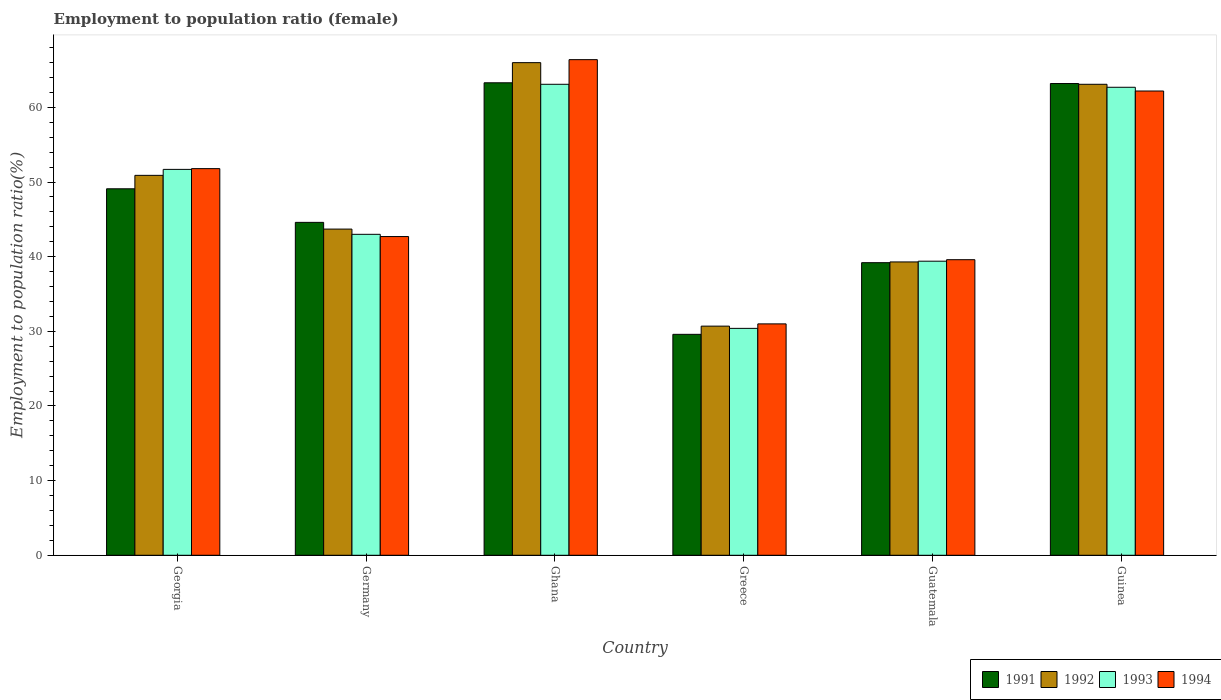Are the number of bars per tick equal to the number of legend labels?
Make the answer very short. Yes. How many bars are there on the 2nd tick from the left?
Make the answer very short. 4. What is the label of the 6th group of bars from the left?
Your answer should be very brief. Guinea. What is the employment to population ratio in 1994 in Germany?
Offer a very short reply. 42.7. Across all countries, what is the maximum employment to population ratio in 1993?
Your response must be concise. 63.1. Across all countries, what is the minimum employment to population ratio in 1992?
Offer a very short reply. 30.7. In which country was the employment to population ratio in 1993 maximum?
Make the answer very short. Ghana. What is the total employment to population ratio in 1993 in the graph?
Ensure brevity in your answer.  290.3. What is the difference between the employment to population ratio in 1994 in Ghana and that in Guatemala?
Offer a terse response. 26.8. What is the difference between the employment to population ratio in 1993 in Guinea and the employment to population ratio in 1994 in Germany?
Provide a short and direct response. 20. What is the average employment to population ratio in 1993 per country?
Your answer should be compact. 48.38. What is the difference between the employment to population ratio of/in 1991 and employment to population ratio of/in 1994 in Guinea?
Your response must be concise. 1. In how many countries, is the employment to population ratio in 1994 greater than 34 %?
Provide a short and direct response. 5. What is the ratio of the employment to population ratio in 1992 in Georgia to that in Germany?
Your answer should be very brief. 1.16. Is the difference between the employment to population ratio in 1991 in Ghana and Guinea greater than the difference between the employment to population ratio in 1994 in Ghana and Guinea?
Keep it short and to the point. No. What is the difference between the highest and the second highest employment to population ratio in 1991?
Offer a very short reply. -14.1. What is the difference between the highest and the lowest employment to population ratio in 1991?
Provide a succinct answer. 33.7. In how many countries, is the employment to population ratio in 1993 greater than the average employment to population ratio in 1993 taken over all countries?
Offer a very short reply. 3. Is it the case that in every country, the sum of the employment to population ratio in 1991 and employment to population ratio in 1993 is greater than the sum of employment to population ratio in 1994 and employment to population ratio in 1992?
Your answer should be very brief. No. What does the 3rd bar from the right in Ghana represents?
Your answer should be compact. 1992. How many bars are there?
Your answer should be compact. 24. Are all the bars in the graph horizontal?
Your response must be concise. No. How many countries are there in the graph?
Your answer should be compact. 6. What is the difference between two consecutive major ticks on the Y-axis?
Make the answer very short. 10. Does the graph contain grids?
Your response must be concise. No. How many legend labels are there?
Make the answer very short. 4. What is the title of the graph?
Your answer should be very brief. Employment to population ratio (female). What is the Employment to population ratio(%) of 1991 in Georgia?
Provide a short and direct response. 49.1. What is the Employment to population ratio(%) of 1992 in Georgia?
Make the answer very short. 50.9. What is the Employment to population ratio(%) in 1993 in Georgia?
Your response must be concise. 51.7. What is the Employment to population ratio(%) in 1994 in Georgia?
Ensure brevity in your answer.  51.8. What is the Employment to population ratio(%) in 1991 in Germany?
Provide a short and direct response. 44.6. What is the Employment to population ratio(%) of 1992 in Germany?
Provide a short and direct response. 43.7. What is the Employment to population ratio(%) in 1994 in Germany?
Give a very brief answer. 42.7. What is the Employment to population ratio(%) in 1991 in Ghana?
Provide a short and direct response. 63.3. What is the Employment to population ratio(%) of 1993 in Ghana?
Your answer should be very brief. 63.1. What is the Employment to population ratio(%) of 1994 in Ghana?
Give a very brief answer. 66.4. What is the Employment to population ratio(%) in 1991 in Greece?
Provide a short and direct response. 29.6. What is the Employment to population ratio(%) of 1992 in Greece?
Make the answer very short. 30.7. What is the Employment to population ratio(%) of 1993 in Greece?
Your response must be concise. 30.4. What is the Employment to population ratio(%) of 1994 in Greece?
Offer a very short reply. 31. What is the Employment to population ratio(%) in 1991 in Guatemala?
Make the answer very short. 39.2. What is the Employment to population ratio(%) in 1992 in Guatemala?
Your answer should be compact. 39.3. What is the Employment to population ratio(%) in 1993 in Guatemala?
Ensure brevity in your answer.  39.4. What is the Employment to population ratio(%) in 1994 in Guatemala?
Offer a very short reply. 39.6. What is the Employment to population ratio(%) in 1991 in Guinea?
Ensure brevity in your answer.  63.2. What is the Employment to population ratio(%) in 1992 in Guinea?
Give a very brief answer. 63.1. What is the Employment to population ratio(%) in 1993 in Guinea?
Your answer should be compact. 62.7. What is the Employment to population ratio(%) of 1994 in Guinea?
Offer a very short reply. 62.2. Across all countries, what is the maximum Employment to population ratio(%) in 1991?
Your answer should be very brief. 63.3. Across all countries, what is the maximum Employment to population ratio(%) in 1992?
Give a very brief answer. 66. Across all countries, what is the maximum Employment to population ratio(%) of 1993?
Make the answer very short. 63.1. Across all countries, what is the maximum Employment to population ratio(%) of 1994?
Ensure brevity in your answer.  66.4. Across all countries, what is the minimum Employment to population ratio(%) in 1991?
Give a very brief answer. 29.6. Across all countries, what is the minimum Employment to population ratio(%) of 1992?
Give a very brief answer. 30.7. Across all countries, what is the minimum Employment to population ratio(%) in 1993?
Provide a succinct answer. 30.4. What is the total Employment to population ratio(%) in 1991 in the graph?
Provide a succinct answer. 289. What is the total Employment to population ratio(%) in 1992 in the graph?
Make the answer very short. 293.7. What is the total Employment to population ratio(%) in 1993 in the graph?
Offer a very short reply. 290.3. What is the total Employment to population ratio(%) in 1994 in the graph?
Your answer should be very brief. 293.7. What is the difference between the Employment to population ratio(%) of 1993 in Georgia and that in Germany?
Offer a very short reply. 8.7. What is the difference between the Employment to population ratio(%) in 1992 in Georgia and that in Ghana?
Offer a very short reply. -15.1. What is the difference between the Employment to population ratio(%) in 1993 in Georgia and that in Ghana?
Provide a succinct answer. -11.4. What is the difference between the Employment to population ratio(%) of 1994 in Georgia and that in Ghana?
Offer a very short reply. -14.6. What is the difference between the Employment to population ratio(%) in 1991 in Georgia and that in Greece?
Give a very brief answer. 19.5. What is the difference between the Employment to population ratio(%) of 1992 in Georgia and that in Greece?
Offer a very short reply. 20.2. What is the difference between the Employment to population ratio(%) of 1993 in Georgia and that in Greece?
Keep it short and to the point. 21.3. What is the difference between the Employment to population ratio(%) in 1994 in Georgia and that in Greece?
Offer a terse response. 20.8. What is the difference between the Employment to population ratio(%) in 1991 in Georgia and that in Guatemala?
Keep it short and to the point. 9.9. What is the difference between the Employment to population ratio(%) of 1992 in Georgia and that in Guatemala?
Provide a short and direct response. 11.6. What is the difference between the Employment to population ratio(%) in 1994 in Georgia and that in Guatemala?
Keep it short and to the point. 12.2. What is the difference between the Employment to population ratio(%) in 1991 in Georgia and that in Guinea?
Give a very brief answer. -14.1. What is the difference between the Employment to population ratio(%) in 1993 in Georgia and that in Guinea?
Offer a terse response. -11. What is the difference between the Employment to population ratio(%) of 1991 in Germany and that in Ghana?
Your answer should be compact. -18.7. What is the difference between the Employment to population ratio(%) of 1992 in Germany and that in Ghana?
Your response must be concise. -22.3. What is the difference between the Employment to population ratio(%) of 1993 in Germany and that in Ghana?
Ensure brevity in your answer.  -20.1. What is the difference between the Employment to population ratio(%) of 1994 in Germany and that in Ghana?
Your answer should be very brief. -23.7. What is the difference between the Employment to population ratio(%) in 1991 in Germany and that in Greece?
Ensure brevity in your answer.  15. What is the difference between the Employment to population ratio(%) of 1994 in Germany and that in Greece?
Provide a succinct answer. 11.7. What is the difference between the Employment to population ratio(%) of 1994 in Germany and that in Guatemala?
Make the answer very short. 3.1. What is the difference between the Employment to population ratio(%) of 1991 in Germany and that in Guinea?
Offer a terse response. -18.6. What is the difference between the Employment to population ratio(%) in 1992 in Germany and that in Guinea?
Keep it short and to the point. -19.4. What is the difference between the Employment to population ratio(%) in 1993 in Germany and that in Guinea?
Your answer should be compact. -19.7. What is the difference between the Employment to population ratio(%) of 1994 in Germany and that in Guinea?
Your answer should be very brief. -19.5. What is the difference between the Employment to population ratio(%) of 1991 in Ghana and that in Greece?
Keep it short and to the point. 33.7. What is the difference between the Employment to population ratio(%) in 1992 in Ghana and that in Greece?
Your response must be concise. 35.3. What is the difference between the Employment to population ratio(%) in 1993 in Ghana and that in Greece?
Provide a short and direct response. 32.7. What is the difference between the Employment to population ratio(%) of 1994 in Ghana and that in Greece?
Ensure brevity in your answer.  35.4. What is the difference between the Employment to population ratio(%) of 1991 in Ghana and that in Guatemala?
Your answer should be very brief. 24.1. What is the difference between the Employment to population ratio(%) of 1992 in Ghana and that in Guatemala?
Offer a terse response. 26.7. What is the difference between the Employment to population ratio(%) of 1993 in Ghana and that in Guatemala?
Make the answer very short. 23.7. What is the difference between the Employment to population ratio(%) of 1994 in Ghana and that in Guatemala?
Ensure brevity in your answer.  26.8. What is the difference between the Employment to population ratio(%) of 1991 in Ghana and that in Guinea?
Your answer should be very brief. 0.1. What is the difference between the Employment to population ratio(%) in 1994 in Ghana and that in Guinea?
Offer a terse response. 4.2. What is the difference between the Employment to population ratio(%) in 1992 in Greece and that in Guatemala?
Your answer should be very brief. -8.6. What is the difference between the Employment to population ratio(%) in 1993 in Greece and that in Guatemala?
Offer a terse response. -9. What is the difference between the Employment to population ratio(%) of 1991 in Greece and that in Guinea?
Make the answer very short. -33.6. What is the difference between the Employment to population ratio(%) in 1992 in Greece and that in Guinea?
Your answer should be very brief. -32.4. What is the difference between the Employment to population ratio(%) of 1993 in Greece and that in Guinea?
Give a very brief answer. -32.3. What is the difference between the Employment to population ratio(%) in 1994 in Greece and that in Guinea?
Your response must be concise. -31.2. What is the difference between the Employment to population ratio(%) of 1991 in Guatemala and that in Guinea?
Your answer should be very brief. -24. What is the difference between the Employment to population ratio(%) of 1992 in Guatemala and that in Guinea?
Provide a succinct answer. -23.8. What is the difference between the Employment to population ratio(%) in 1993 in Guatemala and that in Guinea?
Ensure brevity in your answer.  -23.3. What is the difference between the Employment to population ratio(%) in 1994 in Guatemala and that in Guinea?
Offer a very short reply. -22.6. What is the difference between the Employment to population ratio(%) of 1991 in Georgia and the Employment to population ratio(%) of 1992 in Germany?
Make the answer very short. 5.4. What is the difference between the Employment to population ratio(%) in 1991 in Georgia and the Employment to population ratio(%) in 1993 in Germany?
Offer a very short reply. 6.1. What is the difference between the Employment to population ratio(%) in 1992 in Georgia and the Employment to population ratio(%) in 1994 in Germany?
Provide a short and direct response. 8.2. What is the difference between the Employment to population ratio(%) in 1991 in Georgia and the Employment to population ratio(%) in 1992 in Ghana?
Your response must be concise. -16.9. What is the difference between the Employment to population ratio(%) of 1991 in Georgia and the Employment to population ratio(%) of 1994 in Ghana?
Offer a very short reply. -17.3. What is the difference between the Employment to population ratio(%) of 1992 in Georgia and the Employment to population ratio(%) of 1994 in Ghana?
Offer a terse response. -15.5. What is the difference between the Employment to population ratio(%) in 1993 in Georgia and the Employment to population ratio(%) in 1994 in Ghana?
Give a very brief answer. -14.7. What is the difference between the Employment to population ratio(%) of 1993 in Georgia and the Employment to population ratio(%) of 1994 in Greece?
Give a very brief answer. 20.7. What is the difference between the Employment to population ratio(%) in 1991 in Georgia and the Employment to population ratio(%) in 1992 in Guatemala?
Your answer should be very brief. 9.8. What is the difference between the Employment to population ratio(%) of 1991 in Georgia and the Employment to population ratio(%) of 1993 in Guatemala?
Your answer should be very brief. 9.7. What is the difference between the Employment to population ratio(%) of 1991 in Georgia and the Employment to population ratio(%) of 1994 in Guatemala?
Provide a succinct answer. 9.5. What is the difference between the Employment to population ratio(%) in 1992 in Georgia and the Employment to population ratio(%) in 1993 in Guatemala?
Your answer should be compact. 11.5. What is the difference between the Employment to population ratio(%) of 1991 in Georgia and the Employment to population ratio(%) of 1993 in Guinea?
Provide a succinct answer. -13.6. What is the difference between the Employment to population ratio(%) in 1993 in Georgia and the Employment to population ratio(%) in 1994 in Guinea?
Give a very brief answer. -10.5. What is the difference between the Employment to population ratio(%) of 1991 in Germany and the Employment to population ratio(%) of 1992 in Ghana?
Ensure brevity in your answer.  -21.4. What is the difference between the Employment to population ratio(%) of 1991 in Germany and the Employment to population ratio(%) of 1993 in Ghana?
Your response must be concise. -18.5. What is the difference between the Employment to population ratio(%) in 1991 in Germany and the Employment to population ratio(%) in 1994 in Ghana?
Make the answer very short. -21.8. What is the difference between the Employment to population ratio(%) in 1992 in Germany and the Employment to population ratio(%) in 1993 in Ghana?
Keep it short and to the point. -19.4. What is the difference between the Employment to population ratio(%) in 1992 in Germany and the Employment to population ratio(%) in 1994 in Ghana?
Ensure brevity in your answer.  -22.7. What is the difference between the Employment to population ratio(%) in 1993 in Germany and the Employment to population ratio(%) in 1994 in Ghana?
Keep it short and to the point. -23.4. What is the difference between the Employment to population ratio(%) of 1991 in Germany and the Employment to population ratio(%) of 1992 in Greece?
Your response must be concise. 13.9. What is the difference between the Employment to population ratio(%) of 1992 in Germany and the Employment to population ratio(%) of 1994 in Greece?
Your answer should be compact. 12.7. What is the difference between the Employment to population ratio(%) of 1993 in Germany and the Employment to population ratio(%) of 1994 in Greece?
Ensure brevity in your answer.  12. What is the difference between the Employment to population ratio(%) of 1992 in Germany and the Employment to population ratio(%) of 1994 in Guatemala?
Ensure brevity in your answer.  4.1. What is the difference between the Employment to population ratio(%) in 1993 in Germany and the Employment to population ratio(%) in 1994 in Guatemala?
Keep it short and to the point. 3.4. What is the difference between the Employment to population ratio(%) of 1991 in Germany and the Employment to population ratio(%) of 1992 in Guinea?
Provide a short and direct response. -18.5. What is the difference between the Employment to population ratio(%) in 1991 in Germany and the Employment to population ratio(%) in 1993 in Guinea?
Ensure brevity in your answer.  -18.1. What is the difference between the Employment to population ratio(%) of 1991 in Germany and the Employment to population ratio(%) of 1994 in Guinea?
Keep it short and to the point. -17.6. What is the difference between the Employment to population ratio(%) in 1992 in Germany and the Employment to population ratio(%) in 1994 in Guinea?
Provide a short and direct response. -18.5. What is the difference between the Employment to population ratio(%) in 1993 in Germany and the Employment to population ratio(%) in 1994 in Guinea?
Provide a succinct answer. -19.2. What is the difference between the Employment to population ratio(%) of 1991 in Ghana and the Employment to population ratio(%) of 1992 in Greece?
Your response must be concise. 32.6. What is the difference between the Employment to population ratio(%) in 1991 in Ghana and the Employment to population ratio(%) in 1993 in Greece?
Give a very brief answer. 32.9. What is the difference between the Employment to population ratio(%) in 1991 in Ghana and the Employment to population ratio(%) in 1994 in Greece?
Give a very brief answer. 32.3. What is the difference between the Employment to population ratio(%) of 1992 in Ghana and the Employment to population ratio(%) of 1993 in Greece?
Keep it short and to the point. 35.6. What is the difference between the Employment to population ratio(%) in 1992 in Ghana and the Employment to population ratio(%) in 1994 in Greece?
Your answer should be very brief. 35. What is the difference between the Employment to population ratio(%) in 1993 in Ghana and the Employment to population ratio(%) in 1994 in Greece?
Offer a terse response. 32.1. What is the difference between the Employment to population ratio(%) in 1991 in Ghana and the Employment to population ratio(%) in 1992 in Guatemala?
Your answer should be very brief. 24. What is the difference between the Employment to population ratio(%) in 1991 in Ghana and the Employment to population ratio(%) in 1993 in Guatemala?
Offer a very short reply. 23.9. What is the difference between the Employment to population ratio(%) of 1991 in Ghana and the Employment to population ratio(%) of 1994 in Guatemala?
Ensure brevity in your answer.  23.7. What is the difference between the Employment to population ratio(%) in 1992 in Ghana and the Employment to population ratio(%) in 1993 in Guatemala?
Your response must be concise. 26.6. What is the difference between the Employment to population ratio(%) in 1992 in Ghana and the Employment to population ratio(%) in 1994 in Guatemala?
Ensure brevity in your answer.  26.4. What is the difference between the Employment to population ratio(%) in 1991 in Greece and the Employment to population ratio(%) in 1993 in Guatemala?
Ensure brevity in your answer.  -9.8. What is the difference between the Employment to population ratio(%) in 1991 in Greece and the Employment to population ratio(%) in 1994 in Guatemala?
Make the answer very short. -10. What is the difference between the Employment to population ratio(%) of 1992 in Greece and the Employment to population ratio(%) of 1994 in Guatemala?
Your answer should be compact. -8.9. What is the difference between the Employment to population ratio(%) of 1993 in Greece and the Employment to population ratio(%) of 1994 in Guatemala?
Provide a succinct answer. -9.2. What is the difference between the Employment to population ratio(%) in 1991 in Greece and the Employment to population ratio(%) in 1992 in Guinea?
Ensure brevity in your answer.  -33.5. What is the difference between the Employment to population ratio(%) of 1991 in Greece and the Employment to population ratio(%) of 1993 in Guinea?
Your response must be concise. -33.1. What is the difference between the Employment to population ratio(%) in 1991 in Greece and the Employment to population ratio(%) in 1994 in Guinea?
Your response must be concise. -32.6. What is the difference between the Employment to population ratio(%) in 1992 in Greece and the Employment to population ratio(%) in 1993 in Guinea?
Keep it short and to the point. -32. What is the difference between the Employment to population ratio(%) of 1992 in Greece and the Employment to population ratio(%) of 1994 in Guinea?
Offer a terse response. -31.5. What is the difference between the Employment to population ratio(%) in 1993 in Greece and the Employment to population ratio(%) in 1994 in Guinea?
Provide a succinct answer. -31.8. What is the difference between the Employment to population ratio(%) of 1991 in Guatemala and the Employment to population ratio(%) of 1992 in Guinea?
Provide a succinct answer. -23.9. What is the difference between the Employment to population ratio(%) of 1991 in Guatemala and the Employment to population ratio(%) of 1993 in Guinea?
Provide a short and direct response. -23.5. What is the difference between the Employment to population ratio(%) of 1991 in Guatemala and the Employment to population ratio(%) of 1994 in Guinea?
Make the answer very short. -23. What is the difference between the Employment to population ratio(%) of 1992 in Guatemala and the Employment to population ratio(%) of 1993 in Guinea?
Make the answer very short. -23.4. What is the difference between the Employment to population ratio(%) of 1992 in Guatemala and the Employment to population ratio(%) of 1994 in Guinea?
Ensure brevity in your answer.  -22.9. What is the difference between the Employment to population ratio(%) of 1993 in Guatemala and the Employment to population ratio(%) of 1994 in Guinea?
Keep it short and to the point. -22.8. What is the average Employment to population ratio(%) of 1991 per country?
Give a very brief answer. 48.17. What is the average Employment to population ratio(%) of 1992 per country?
Give a very brief answer. 48.95. What is the average Employment to population ratio(%) in 1993 per country?
Provide a succinct answer. 48.38. What is the average Employment to population ratio(%) of 1994 per country?
Provide a short and direct response. 48.95. What is the difference between the Employment to population ratio(%) in 1991 and Employment to population ratio(%) in 1992 in Georgia?
Ensure brevity in your answer.  -1.8. What is the difference between the Employment to population ratio(%) in 1991 and Employment to population ratio(%) in 1993 in Georgia?
Your answer should be compact. -2.6. What is the difference between the Employment to population ratio(%) in 1992 and Employment to population ratio(%) in 1993 in Georgia?
Give a very brief answer. -0.8. What is the difference between the Employment to population ratio(%) in 1993 and Employment to population ratio(%) in 1994 in Georgia?
Provide a succinct answer. -0.1. What is the difference between the Employment to population ratio(%) in 1991 and Employment to population ratio(%) in 1993 in Germany?
Your answer should be compact. 1.6. What is the difference between the Employment to population ratio(%) of 1991 and Employment to population ratio(%) of 1994 in Germany?
Your answer should be very brief. 1.9. What is the difference between the Employment to population ratio(%) of 1992 and Employment to population ratio(%) of 1994 in Germany?
Your answer should be compact. 1. What is the difference between the Employment to population ratio(%) in 1991 and Employment to population ratio(%) in 1994 in Ghana?
Offer a terse response. -3.1. What is the difference between the Employment to population ratio(%) of 1992 and Employment to population ratio(%) of 1993 in Ghana?
Provide a short and direct response. 2.9. What is the difference between the Employment to population ratio(%) in 1992 and Employment to population ratio(%) in 1994 in Ghana?
Your answer should be very brief. -0.4. What is the difference between the Employment to population ratio(%) of 1993 and Employment to population ratio(%) of 1994 in Ghana?
Your response must be concise. -3.3. What is the difference between the Employment to population ratio(%) of 1991 and Employment to population ratio(%) of 1993 in Greece?
Your response must be concise. -0.8. What is the difference between the Employment to population ratio(%) in 1991 and Employment to population ratio(%) in 1992 in Guatemala?
Provide a short and direct response. -0.1. What is the difference between the Employment to population ratio(%) in 1991 and Employment to population ratio(%) in 1994 in Guatemala?
Keep it short and to the point. -0.4. What is the difference between the Employment to population ratio(%) of 1992 and Employment to population ratio(%) of 1994 in Guatemala?
Your answer should be compact. -0.3. What is the difference between the Employment to population ratio(%) of 1991 and Employment to population ratio(%) of 1992 in Guinea?
Keep it short and to the point. 0.1. What is the difference between the Employment to population ratio(%) of 1991 and Employment to population ratio(%) of 1993 in Guinea?
Make the answer very short. 0.5. What is the difference between the Employment to population ratio(%) in 1992 and Employment to population ratio(%) in 1993 in Guinea?
Give a very brief answer. 0.4. What is the difference between the Employment to population ratio(%) of 1993 and Employment to population ratio(%) of 1994 in Guinea?
Keep it short and to the point. 0.5. What is the ratio of the Employment to population ratio(%) in 1991 in Georgia to that in Germany?
Keep it short and to the point. 1.1. What is the ratio of the Employment to population ratio(%) of 1992 in Georgia to that in Germany?
Give a very brief answer. 1.16. What is the ratio of the Employment to population ratio(%) of 1993 in Georgia to that in Germany?
Offer a very short reply. 1.2. What is the ratio of the Employment to population ratio(%) in 1994 in Georgia to that in Germany?
Make the answer very short. 1.21. What is the ratio of the Employment to population ratio(%) in 1991 in Georgia to that in Ghana?
Provide a succinct answer. 0.78. What is the ratio of the Employment to population ratio(%) of 1992 in Georgia to that in Ghana?
Your response must be concise. 0.77. What is the ratio of the Employment to population ratio(%) in 1993 in Georgia to that in Ghana?
Offer a terse response. 0.82. What is the ratio of the Employment to population ratio(%) in 1994 in Georgia to that in Ghana?
Offer a terse response. 0.78. What is the ratio of the Employment to population ratio(%) of 1991 in Georgia to that in Greece?
Your response must be concise. 1.66. What is the ratio of the Employment to population ratio(%) of 1992 in Georgia to that in Greece?
Make the answer very short. 1.66. What is the ratio of the Employment to population ratio(%) of 1993 in Georgia to that in Greece?
Keep it short and to the point. 1.7. What is the ratio of the Employment to population ratio(%) of 1994 in Georgia to that in Greece?
Make the answer very short. 1.67. What is the ratio of the Employment to population ratio(%) in 1991 in Georgia to that in Guatemala?
Your answer should be compact. 1.25. What is the ratio of the Employment to population ratio(%) of 1992 in Georgia to that in Guatemala?
Offer a very short reply. 1.3. What is the ratio of the Employment to population ratio(%) of 1993 in Georgia to that in Guatemala?
Offer a very short reply. 1.31. What is the ratio of the Employment to population ratio(%) in 1994 in Georgia to that in Guatemala?
Your answer should be very brief. 1.31. What is the ratio of the Employment to population ratio(%) in 1991 in Georgia to that in Guinea?
Make the answer very short. 0.78. What is the ratio of the Employment to population ratio(%) in 1992 in Georgia to that in Guinea?
Ensure brevity in your answer.  0.81. What is the ratio of the Employment to population ratio(%) of 1993 in Georgia to that in Guinea?
Ensure brevity in your answer.  0.82. What is the ratio of the Employment to population ratio(%) in 1994 in Georgia to that in Guinea?
Keep it short and to the point. 0.83. What is the ratio of the Employment to population ratio(%) of 1991 in Germany to that in Ghana?
Your answer should be very brief. 0.7. What is the ratio of the Employment to population ratio(%) in 1992 in Germany to that in Ghana?
Offer a very short reply. 0.66. What is the ratio of the Employment to population ratio(%) of 1993 in Germany to that in Ghana?
Keep it short and to the point. 0.68. What is the ratio of the Employment to population ratio(%) of 1994 in Germany to that in Ghana?
Your answer should be very brief. 0.64. What is the ratio of the Employment to population ratio(%) of 1991 in Germany to that in Greece?
Give a very brief answer. 1.51. What is the ratio of the Employment to population ratio(%) in 1992 in Germany to that in Greece?
Make the answer very short. 1.42. What is the ratio of the Employment to population ratio(%) in 1993 in Germany to that in Greece?
Ensure brevity in your answer.  1.41. What is the ratio of the Employment to population ratio(%) in 1994 in Germany to that in Greece?
Offer a terse response. 1.38. What is the ratio of the Employment to population ratio(%) in 1991 in Germany to that in Guatemala?
Provide a succinct answer. 1.14. What is the ratio of the Employment to population ratio(%) of 1992 in Germany to that in Guatemala?
Provide a succinct answer. 1.11. What is the ratio of the Employment to population ratio(%) in 1993 in Germany to that in Guatemala?
Your response must be concise. 1.09. What is the ratio of the Employment to population ratio(%) in 1994 in Germany to that in Guatemala?
Offer a very short reply. 1.08. What is the ratio of the Employment to population ratio(%) in 1991 in Germany to that in Guinea?
Provide a short and direct response. 0.71. What is the ratio of the Employment to population ratio(%) of 1992 in Germany to that in Guinea?
Offer a very short reply. 0.69. What is the ratio of the Employment to population ratio(%) in 1993 in Germany to that in Guinea?
Make the answer very short. 0.69. What is the ratio of the Employment to population ratio(%) in 1994 in Germany to that in Guinea?
Offer a terse response. 0.69. What is the ratio of the Employment to population ratio(%) in 1991 in Ghana to that in Greece?
Provide a succinct answer. 2.14. What is the ratio of the Employment to population ratio(%) of 1992 in Ghana to that in Greece?
Provide a short and direct response. 2.15. What is the ratio of the Employment to population ratio(%) of 1993 in Ghana to that in Greece?
Offer a terse response. 2.08. What is the ratio of the Employment to population ratio(%) in 1994 in Ghana to that in Greece?
Ensure brevity in your answer.  2.14. What is the ratio of the Employment to population ratio(%) of 1991 in Ghana to that in Guatemala?
Offer a terse response. 1.61. What is the ratio of the Employment to population ratio(%) of 1992 in Ghana to that in Guatemala?
Ensure brevity in your answer.  1.68. What is the ratio of the Employment to population ratio(%) of 1993 in Ghana to that in Guatemala?
Offer a very short reply. 1.6. What is the ratio of the Employment to population ratio(%) of 1994 in Ghana to that in Guatemala?
Ensure brevity in your answer.  1.68. What is the ratio of the Employment to population ratio(%) in 1991 in Ghana to that in Guinea?
Your response must be concise. 1. What is the ratio of the Employment to population ratio(%) in 1992 in Ghana to that in Guinea?
Ensure brevity in your answer.  1.05. What is the ratio of the Employment to population ratio(%) of 1993 in Ghana to that in Guinea?
Provide a short and direct response. 1.01. What is the ratio of the Employment to population ratio(%) of 1994 in Ghana to that in Guinea?
Offer a terse response. 1.07. What is the ratio of the Employment to population ratio(%) in 1991 in Greece to that in Guatemala?
Make the answer very short. 0.76. What is the ratio of the Employment to population ratio(%) of 1992 in Greece to that in Guatemala?
Ensure brevity in your answer.  0.78. What is the ratio of the Employment to population ratio(%) in 1993 in Greece to that in Guatemala?
Give a very brief answer. 0.77. What is the ratio of the Employment to population ratio(%) in 1994 in Greece to that in Guatemala?
Offer a terse response. 0.78. What is the ratio of the Employment to population ratio(%) of 1991 in Greece to that in Guinea?
Offer a terse response. 0.47. What is the ratio of the Employment to population ratio(%) of 1992 in Greece to that in Guinea?
Your response must be concise. 0.49. What is the ratio of the Employment to population ratio(%) in 1993 in Greece to that in Guinea?
Keep it short and to the point. 0.48. What is the ratio of the Employment to population ratio(%) in 1994 in Greece to that in Guinea?
Ensure brevity in your answer.  0.5. What is the ratio of the Employment to population ratio(%) in 1991 in Guatemala to that in Guinea?
Your answer should be compact. 0.62. What is the ratio of the Employment to population ratio(%) of 1992 in Guatemala to that in Guinea?
Your answer should be compact. 0.62. What is the ratio of the Employment to population ratio(%) in 1993 in Guatemala to that in Guinea?
Ensure brevity in your answer.  0.63. What is the ratio of the Employment to population ratio(%) in 1994 in Guatemala to that in Guinea?
Your answer should be very brief. 0.64. What is the difference between the highest and the second highest Employment to population ratio(%) in 1991?
Provide a succinct answer. 0.1. What is the difference between the highest and the lowest Employment to population ratio(%) in 1991?
Your response must be concise. 33.7. What is the difference between the highest and the lowest Employment to population ratio(%) of 1992?
Provide a short and direct response. 35.3. What is the difference between the highest and the lowest Employment to population ratio(%) of 1993?
Give a very brief answer. 32.7. What is the difference between the highest and the lowest Employment to population ratio(%) in 1994?
Offer a very short reply. 35.4. 